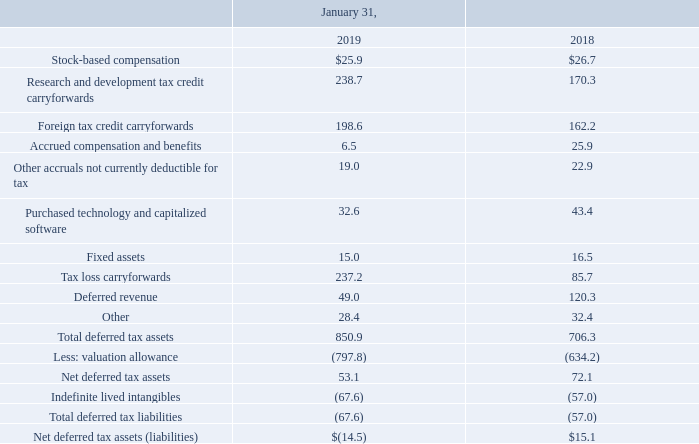Significant components of Autodesk’s deferred tax assets and liabilities are as follows
Autodesk’s tax expense is primarily driven by tax expense in foreign locations, withholding taxes on payments made to the U.S. from foreign sources, and tax amortization on indefinite-lived intangibles offset by a tax benefit resulting from release of uncertain tax positions upon finalization of IRS examination and release of valuation allowance from acquired deferred tax liabilities.
Autodesk regularly assesses the need for a valuation allowance against its deferred tax assets. In making that assessment, Autodesk considers both positive and negative evidence, whether it is more likely than not that some or all of the deferred tax assets will not be realized. In evaluating the need for a valuation allowance, Autodesk considered cumulative losses arising from the Company's business model transition as a significant piece of negative evidence. Consequently, Autodesk determined that a valuation allowance was required on the accumulated U.S., Canada and Singapore tax attributes. In the current year, the U.S. created incremental deferred tax assets, primarily operating losses, foreign tax and R&D credits, Singapore generated operating losses and Canada generated R&D credits. These U.S. and Singapore deferred tax attributes have been offset by a full valuation allowance. The valuation allowance increased by $163.6 million in fiscal 2019 primarily due to the generation of deferred tax attributes. The valuation allowance decreased by $113.8 million, and increased $352.4 million in fiscal 2018, and 2017, respectively, primarily related to U.S. Tax Act reduction in rate in fiscal 2018 and U.S. and Canadian deferred tax attributes generated in fiscal 2017. As Autodesk continually strives to optimize the overall business model, tax planning strategies may become feasible and prudent allowing the Company to realize many of the deferred tax assets that are offset by a valuation allowance; therefore, Autodesk will continue to evaluate the ability to utilize the net deferred tax assets each quarter, both in the U.S. and in foreign jurisdictions, based on all available evidence, both positive and negative.
The Tax Act was signed into law on December 22, 2017 and provided broad and significant changes to the U.S. corporate income tax regime. In light of our fiscal year-end, the Tax Act reduced the statutory federal corporate rate from 35% to 33.81% for fiscal 2018 and to 21% for fiscal 2019 and forward. The Tax Act also, among many other provisions, imposed a one-time mandatory tax on accumulated earnings of foreign subsidiaries (commonly referred to as the "transition tax"), subjected the deemed intangible income of our foreign subsidiaries to current U.S. taxation (commonly referred to as "GILTI"), provided for a full dividends received deduction upon repatriation of untaxed earnings of our foreign subsidiaries, imposed a minimum taxation (without most tax credits) on modified taxable income, which is generally taxable income without deductions for payments to related foreign companies (commonly referred to as “BEAT”), modified the accelerated depreciation deduction rules, and made updates to the deductibility of certain expenses. We have completed our determination of the accounting implications of the Tax Act on our tax accruals.
We recorded a tax benefit of the Tax Act in our financial statements as of January 31, 2018 of approximately $32.3 million mainly driven by the corporate rate remeasurement of the indefinite-lived intangible deferred tax liability.
As of January 31, 2018, we estimated taxable income associated with offshore earnings of $831.5 million, and as of January 31, 2019, we adjusted the taxable income to $819.6 million to reflect the impact of Treasury Regulations issued in the fourth quarter of fiscal 2019. Transition tax related to adjustments in the offshore earnings resulted in no impact to the effective tax rate as it is primarily offset by net operating losses that are subject to a full valuation allowance. As a result of the transition tax, we recorded a deferred tax asset of approximately $45.1 million for foreign tax credits, which are also subject to a full valuation allowance.
What is Autodesk's tax expense primarily driven by? Autodesk’s tax expense is primarily driven by tax expense in foreign locations, withholding taxes on payments made to the u.s. from foreign sources, and tax amortization on indefinite-lived intangibles offset by a tax benefit resulting from release of uncertain tax positions upon finalization of irs examination and release of valuation allowance from acquired deferred tax liabilities. What was the deferred revenue for as of January 31, 2019?
Answer scale should be: million. 49.0. What were the fixed assets in 2018?
Answer scale should be: million. 16.5. What is the change in the total deferred tax assets from 2018 to 2019?
Answer scale should be: million. 850.9-706.3
Answer: 144.6. What is the change in stock-based compensation from 2018 to 2019?
Answer scale should be: million. $26.7-$25.9
Answer: 0.8. What is the average stock-based compensation for the three year period from 2018 to 2019?
Answer scale should be: million. (25.9+26.7)/2 
Answer: 26.3. 